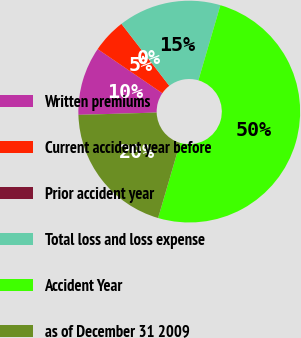<chart> <loc_0><loc_0><loc_500><loc_500><pie_chart><fcel>Written premiums<fcel>Current accident year before<fcel>Prior accident year<fcel>Total loss and loss expense<fcel>Accident Year<fcel>as of December 31 2009<nl><fcel>10.0%<fcel>5.0%<fcel>0.0%<fcel>15.0%<fcel>49.99%<fcel>20.0%<nl></chart> 